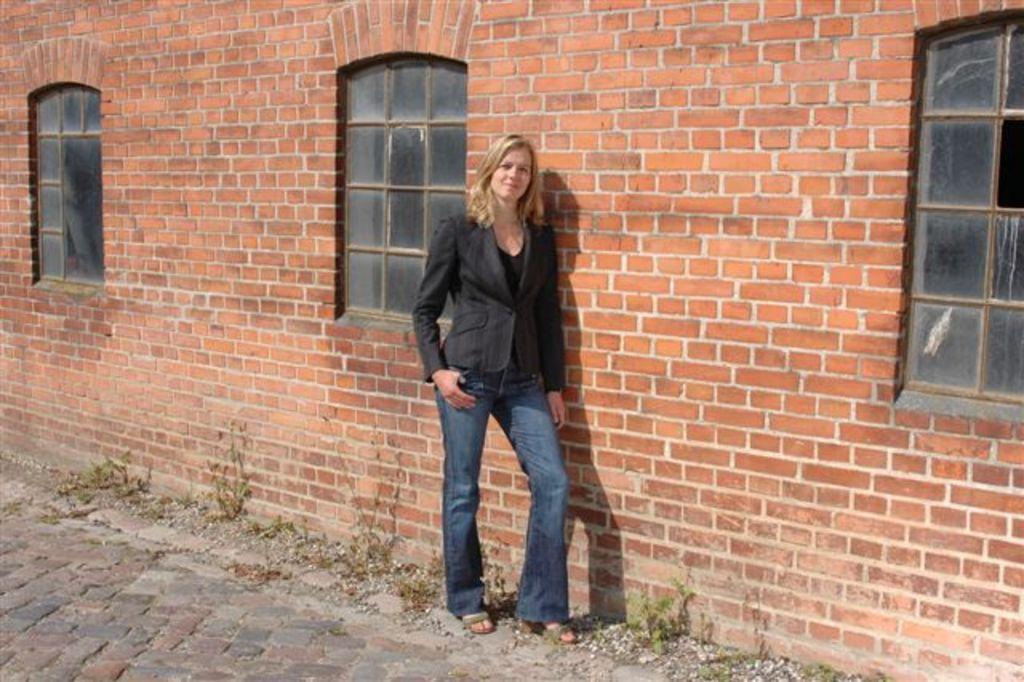In one or two sentences, can you explain what this image depicts? In this picture I can see a woman standing, and in the background there is a wall with windows. 